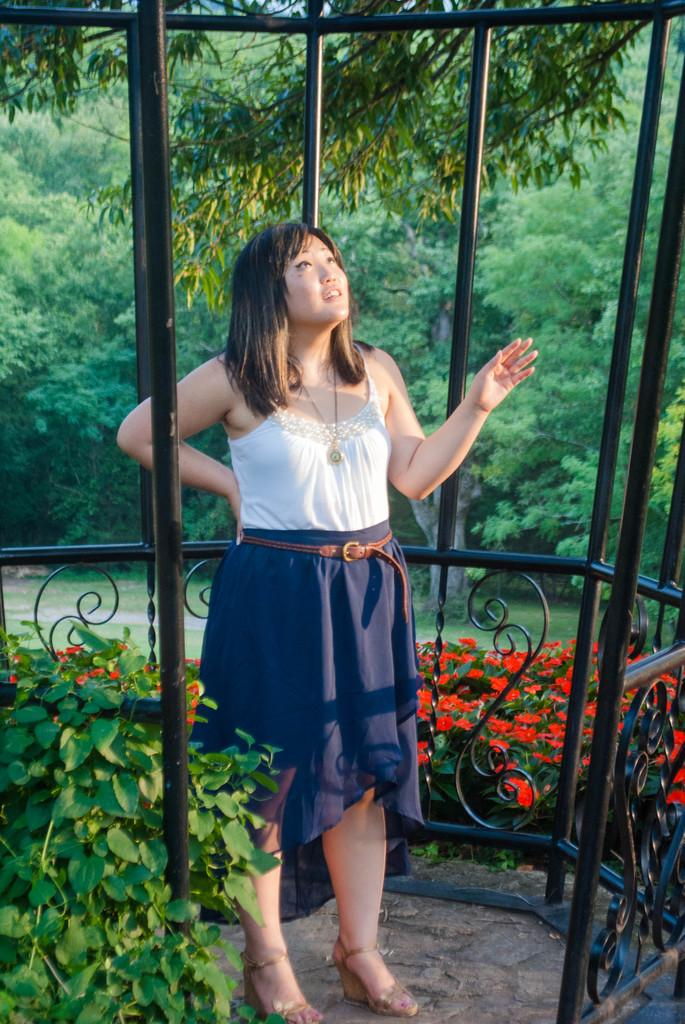Who is present in the image? There is a woman in the image. What type of vegetation can be seen in the image? There are plants and flowers in the image. What can be seen in the background of the image? There are trees in the background of the image. What type of advice is the woman giving in the image? There is no indication in the image that the woman is giving advice, so it cannot be determined from the picture. 